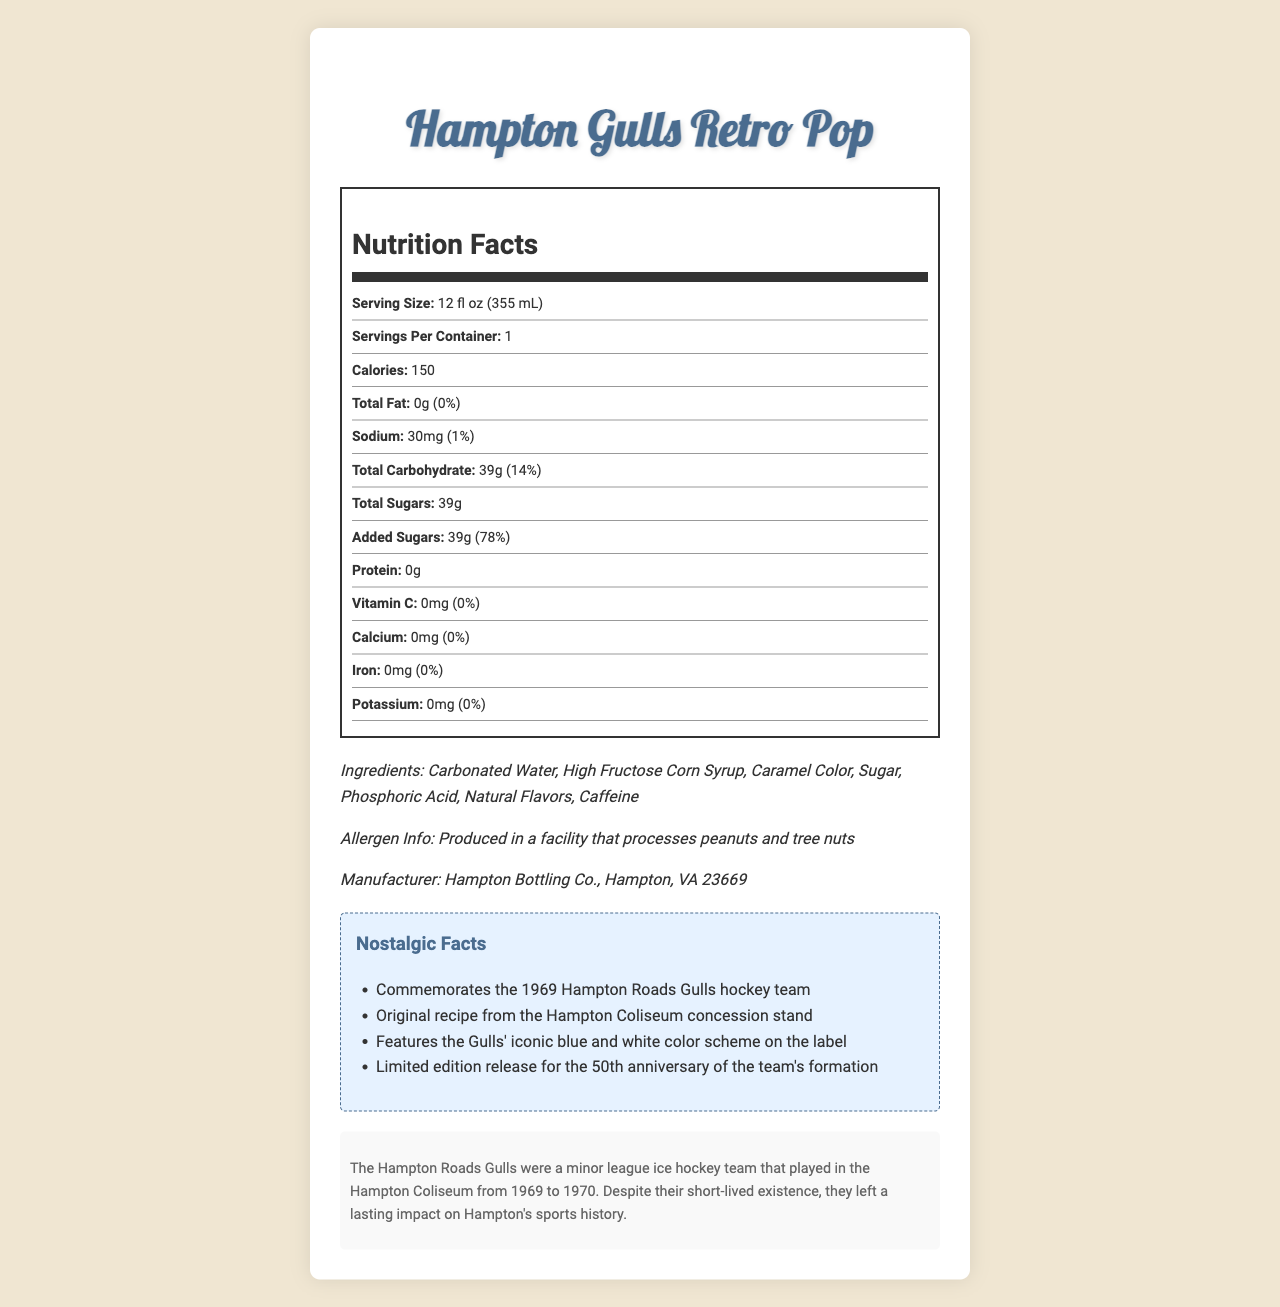What is the serving size of Hampton Gulls Retro Pop? The serving size is clearly mentioned in the document as 12 fl oz (355 mL).
Answer: 12 fl oz (355 mL) How many calories are in one serving of Hampton Gulls Retro Pop? The document states that there are 150 calories per serving.
Answer: 150 What amount of sodium does one serving contain? The document lists the sodium content as 30mg per serving.
Answer: 30mg What is the total amount of sugars in the Hampton Gulls Retro Pop? The total sugars amount is listed in the nutritional facts as 39g.
Answer: 39g What percentage of the daily value of added sugars does one serving have? According to the nutrition facts, added sugars are 78% of the daily value.
Answer: 78% Which of the following nutrients is not present in the Hampton Gulls Retro Pop? A. Vitamin C B. Calcium C. Iron D. All of the above The nutrition label indicates that Vitamin C, Calcium, and Iron all have 0mg, meaning none of these nutrients are present.
Answer: D. All of the above Which ingredient is listed first in the ingredients section? A. High Fructose Corn Syrup B. Caffeine C. Carbonated Water D. Caramel Color The ingredient list begins with Carbonated Water, making it the first ingredient mentioned.
Answer: C. Carbonated Water Is the Hampton Gulls Retro Pop produced in a facility that processes nuts? The allergen information section mentions that it is produced in a facility that processes peanuts and tree nuts.
Answer: Yes Which unique label design element is used to simulate the appearance of age? The document mentions that the label includes worn edges to simulate age as part of the vintage-style elements.
Answer: Worn edges What is the main theme or purpose of the Hampton Gulls Retro Pop? The nostalgic facts section indicates that the soda pop commemorates the 1969 Hampton Roads Gulls hockey team.
Answer: To commemorate the 1969 Hampton Roads Gulls hockey team Describe the main elements included in the document. The main elements are the nutritional composition of the soda, historical references to the Hampton Roads Gulls, and design components meant to invoke nostalgia.
Answer: The document details the nutrition facts and ingredients of the Hampton Gulls Retro Pop, including serving size, calorie content, and nutritional percentages. It also includes nostalgic facts about the 1969 Hampton Roads Gulls hockey team, the product's historical note, allergen information, and manufacture details. The visual presentation includes vintage-style elements like retro cursive fonts and worn edges. What is the percentage of daily value for total fat in Hampton Gulls Retro Pop? The document states that the total fat amount is 0g and its daily value percentage is also 0%.
Answer: 0% Which manufacturer produces the Hampton Gulls Retro Pop? A. Hampton Bottling Co. B. Hampton Sodas Inc. C. Gulls Beverage Co. The document specifies that Hampton Bottling Co. in Hampton, VA 23669 is the manufacturer.
Answer: A. Hampton Bottling Co. What year did the Hampton Roads Gulls begin playing at the Hampton Coliseum? The historical note mentions that the Hampton Roads Gulls began playing in 1969.
Answer: 1969 What is the significance of the Hampton Gulls Retro Pop's color scheme on the label? The nostalgic facts section states that the label features the Gulls' iconic blue and white color scheme.
Answer: It features the Gulls' iconic blue and white color scheme What is the recipe origin of the Hampton Gulls Retro Pop? The nostalgic facts mention that the original recipe is from the Hampton Coliseum concession stand.
Answer: Hampton Coliseum concession stand How long did the Hampton Roads Gulls hockey team exist? The historical note states that the team played from 1969 to 1970, indicating a single year of existence.
Answer: 1 year What are the daily value percentages for Vitamin C, Calcium, Iron, and Potassium? According to the nutrition facts shown, the daily value percentages for Vitamin C, Calcium, Iron, and Potassium are all 0%.
Answer: 0% for all Was the Hampton Gulls Retro Pop initially released to celebrate the 100th anniversary of the Hampton Roads Gulls? The document mentions it was released for the 50th anniversary of the team’s formation, not the 100th.
Answer: No What is the caffeine content in one serving of Hampton Gulls Retro Pop? The document does not specify the amount of caffeine in the beverage, only that it is one of the ingredients.
Answer: Not enough information 